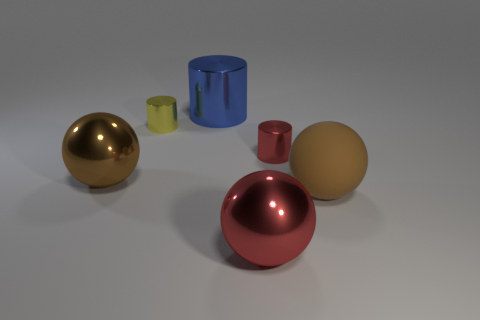Subtract all red metal balls. How many balls are left? 2 Add 2 tiny yellow spheres. How many objects exist? 8 Subtract all gray blocks. How many brown balls are left? 2 Subtract all brown balls. How many balls are left? 1 Subtract 1 balls. How many balls are left? 2 Add 5 big metallic things. How many big metallic things are left? 8 Add 4 yellow metallic objects. How many yellow metallic objects exist? 5 Subtract 0 blue spheres. How many objects are left? 6 Subtract all gray cylinders. Subtract all yellow balls. How many cylinders are left? 3 Subtract all large rubber things. Subtract all large red metallic things. How many objects are left? 4 